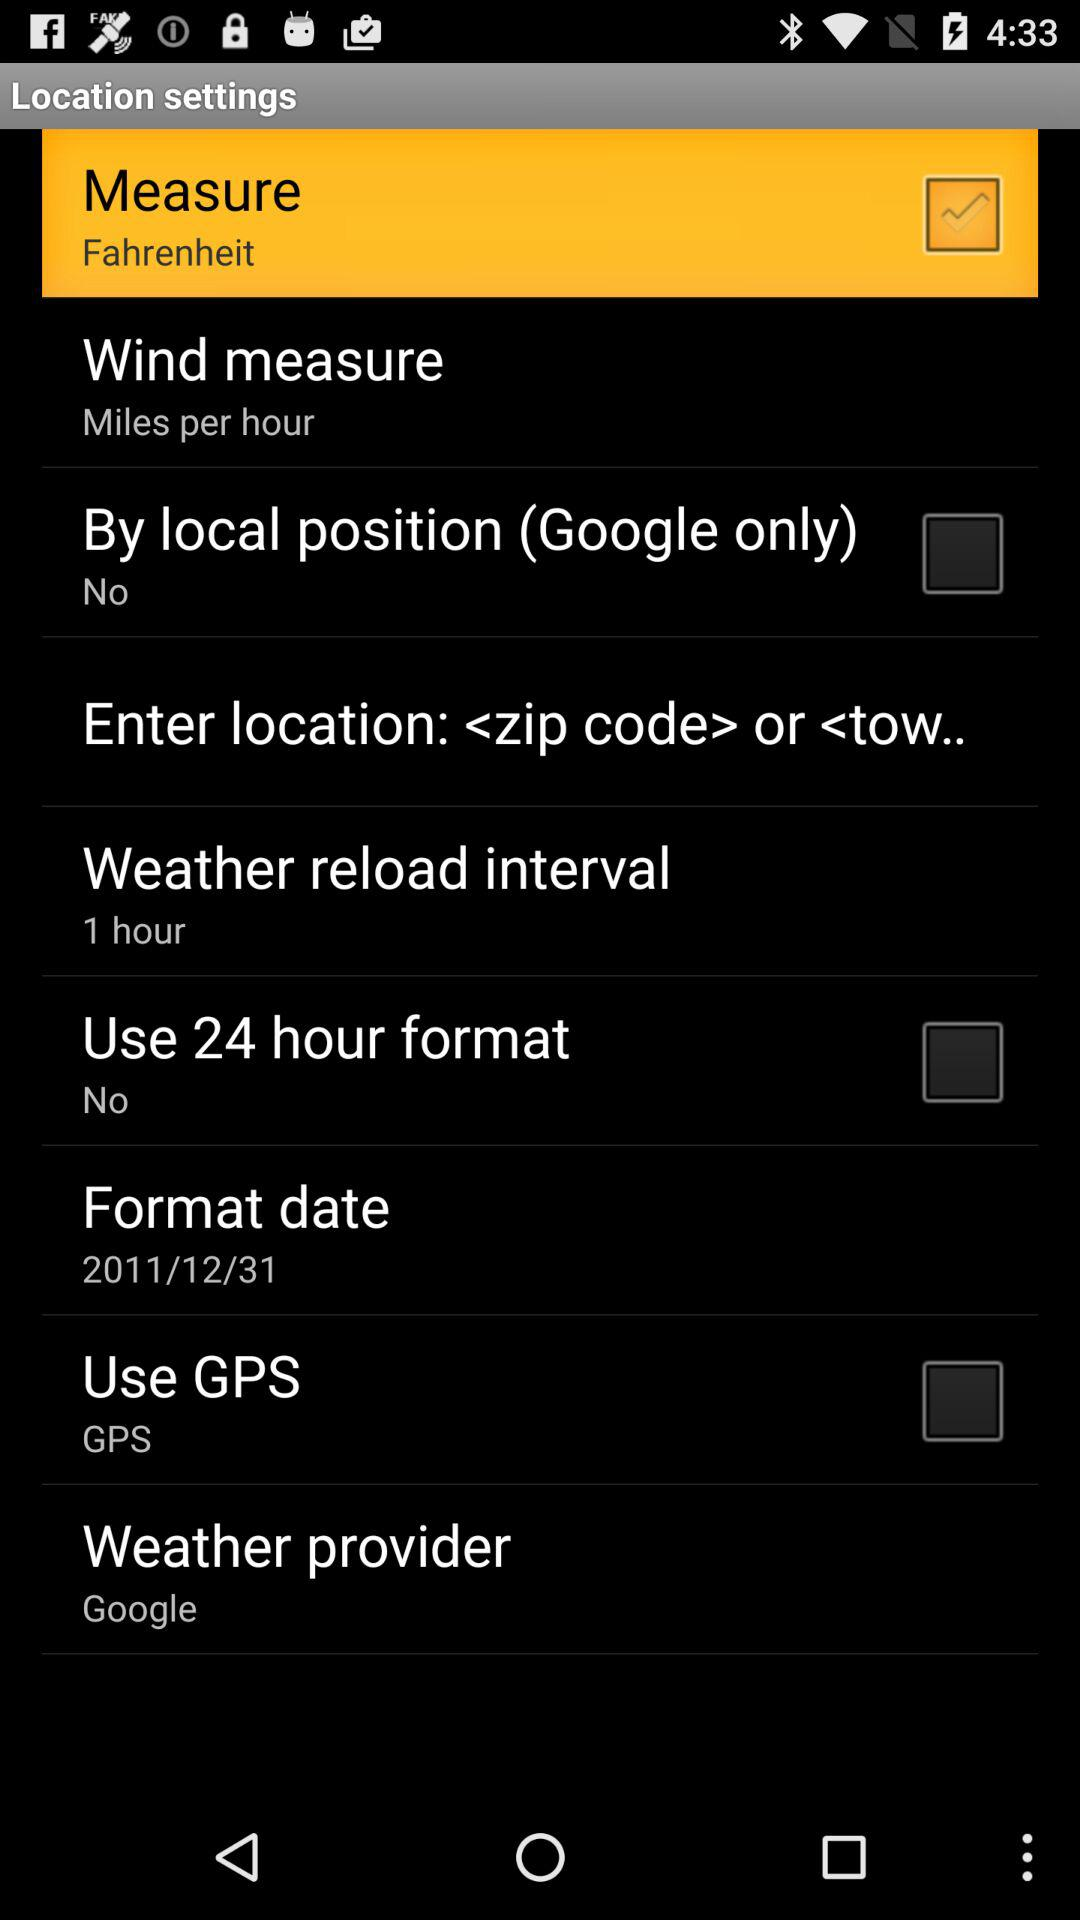What is the weather reload interval? The weather reload interval is 1 hour. 